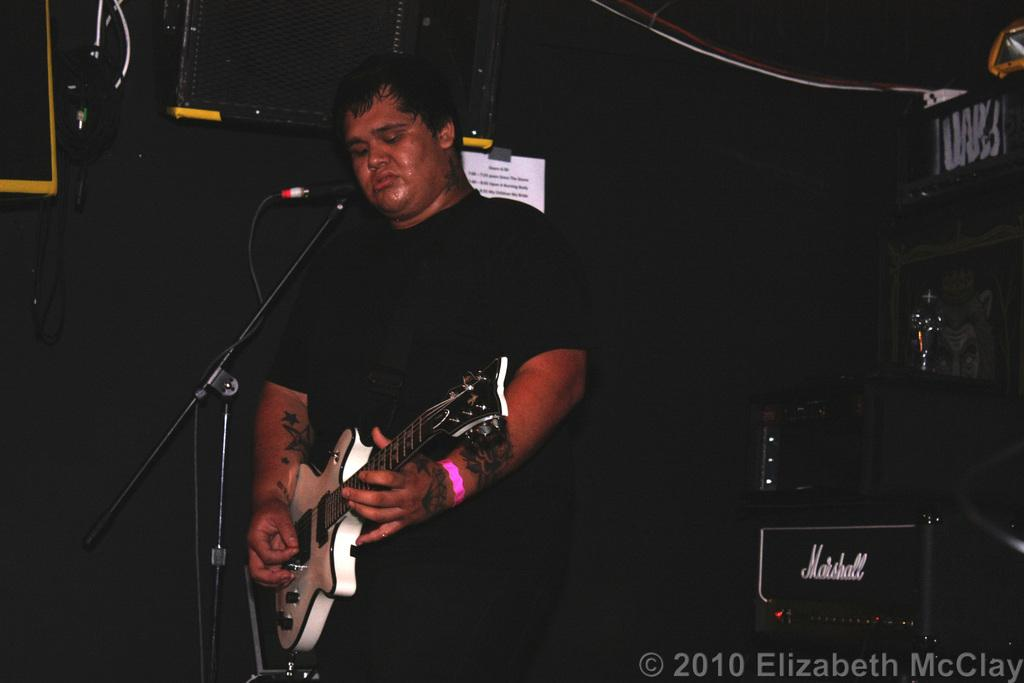What is the person in the image doing? The person is holding a guitar. What is the person wearing? The person is dressed in black. What object is the person standing in front of? The person is standing in front of a microphone. What is the color of the background in the image? The background of the image is black. What type of base can be seen supporting the person in the image? There is no base visible in the image; the person is standing in front of a microphone. What type of prose is being recited by the person in the image? There is no indication in the image that the person is reciting any prose; they are holding a guitar. 